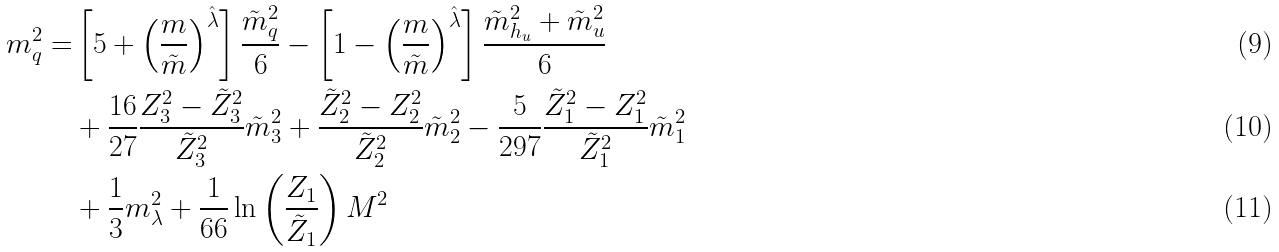<formula> <loc_0><loc_0><loc_500><loc_500>m _ { q } ^ { 2 } = & \left [ 5 + \left ( \frac { m } { \tilde { m } } \right ) ^ { \hat { \lambda } } \right ] \frac { \tilde { m } _ { q } ^ { 2 } } { 6 } - \left [ 1 - \left ( \frac { m } { \tilde { m } } \right ) ^ { \hat { \lambda } } \right ] \frac { \tilde { m } _ { h _ { u } } ^ { 2 } + \tilde { m } _ { u } ^ { 2 } } { 6 } \\ & + \frac { 1 6 } { 2 7 } \frac { Z _ { 3 } ^ { 2 } - \tilde { Z } _ { 3 } ^ { 2 } } { \tilde { Z } _ { 3 } ^ { 2 } } \tilde { m } _ { 3 } ^ { 2 } + \frac { \tilde { Z } _ { 2 } ^ { 2 } - Z _ { 2 } ^ { 2 } } { \tilde { Z } _ { 2 } ^ { 2 } } \tilde { m } _ { 2 } ^ { 2 } - \frac { 5 } { 2 9 7 } \frac { \tilde { Z } _ { 1 } ^ { 2 } - Z _ { 1 } ^ { 2 } } { \tilde { Z } _ { 1 } ^ { 2 } } \tilde { m } _ { 1 } ^ { 2 } \\ & + \frac { 1 } { 3 } m _ { \lambda } ^ { 2 } + \frac { 1 } { 6 6 } \ln \left ( \frac { Z _ { 1 } } { \tilde { Z } _ { 1 } } \right ) M ^ { 2 }</formula> 